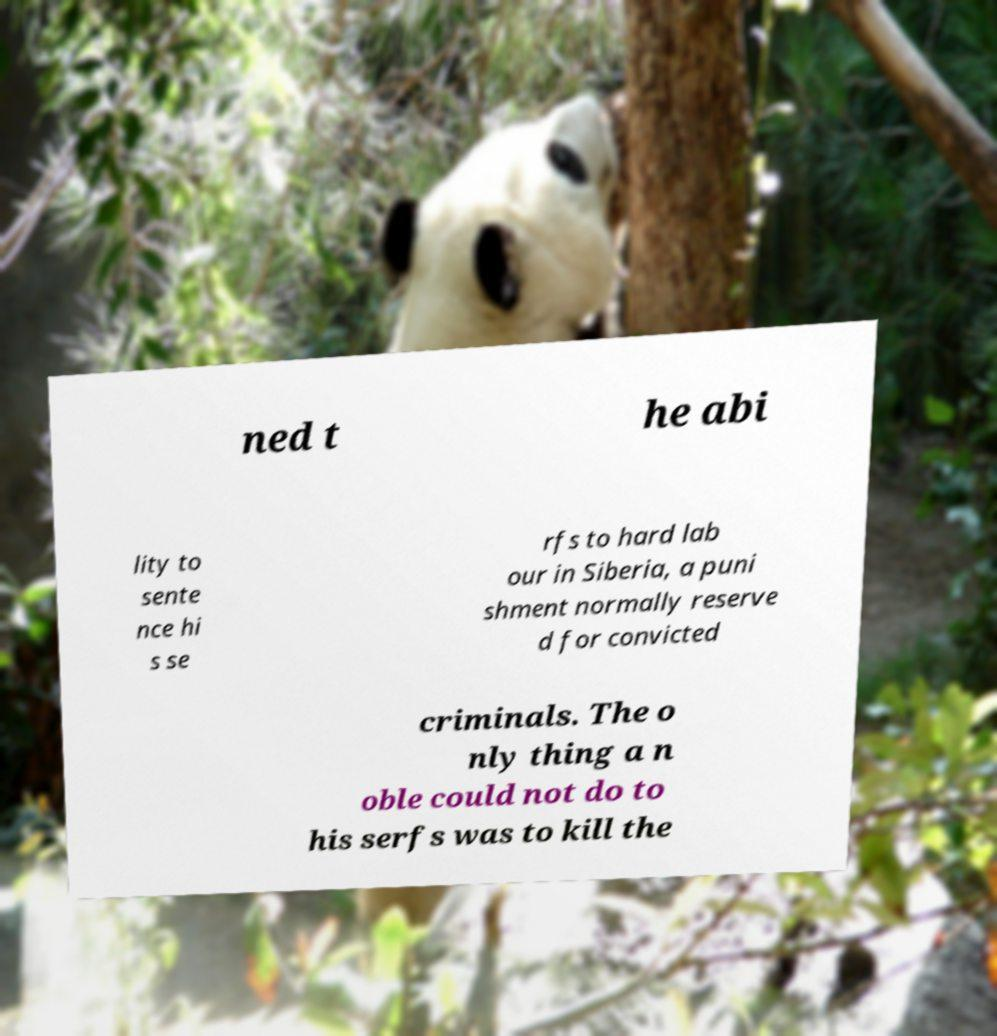Please identify and transcribe the text found in this image. ned t he abi lity to sente nce hi s se rfs to hard lab our in Siberia, a puni shment normally reserve d for convicted criminals. The o nly thing a n oble could not do to his serfs was to kill the 